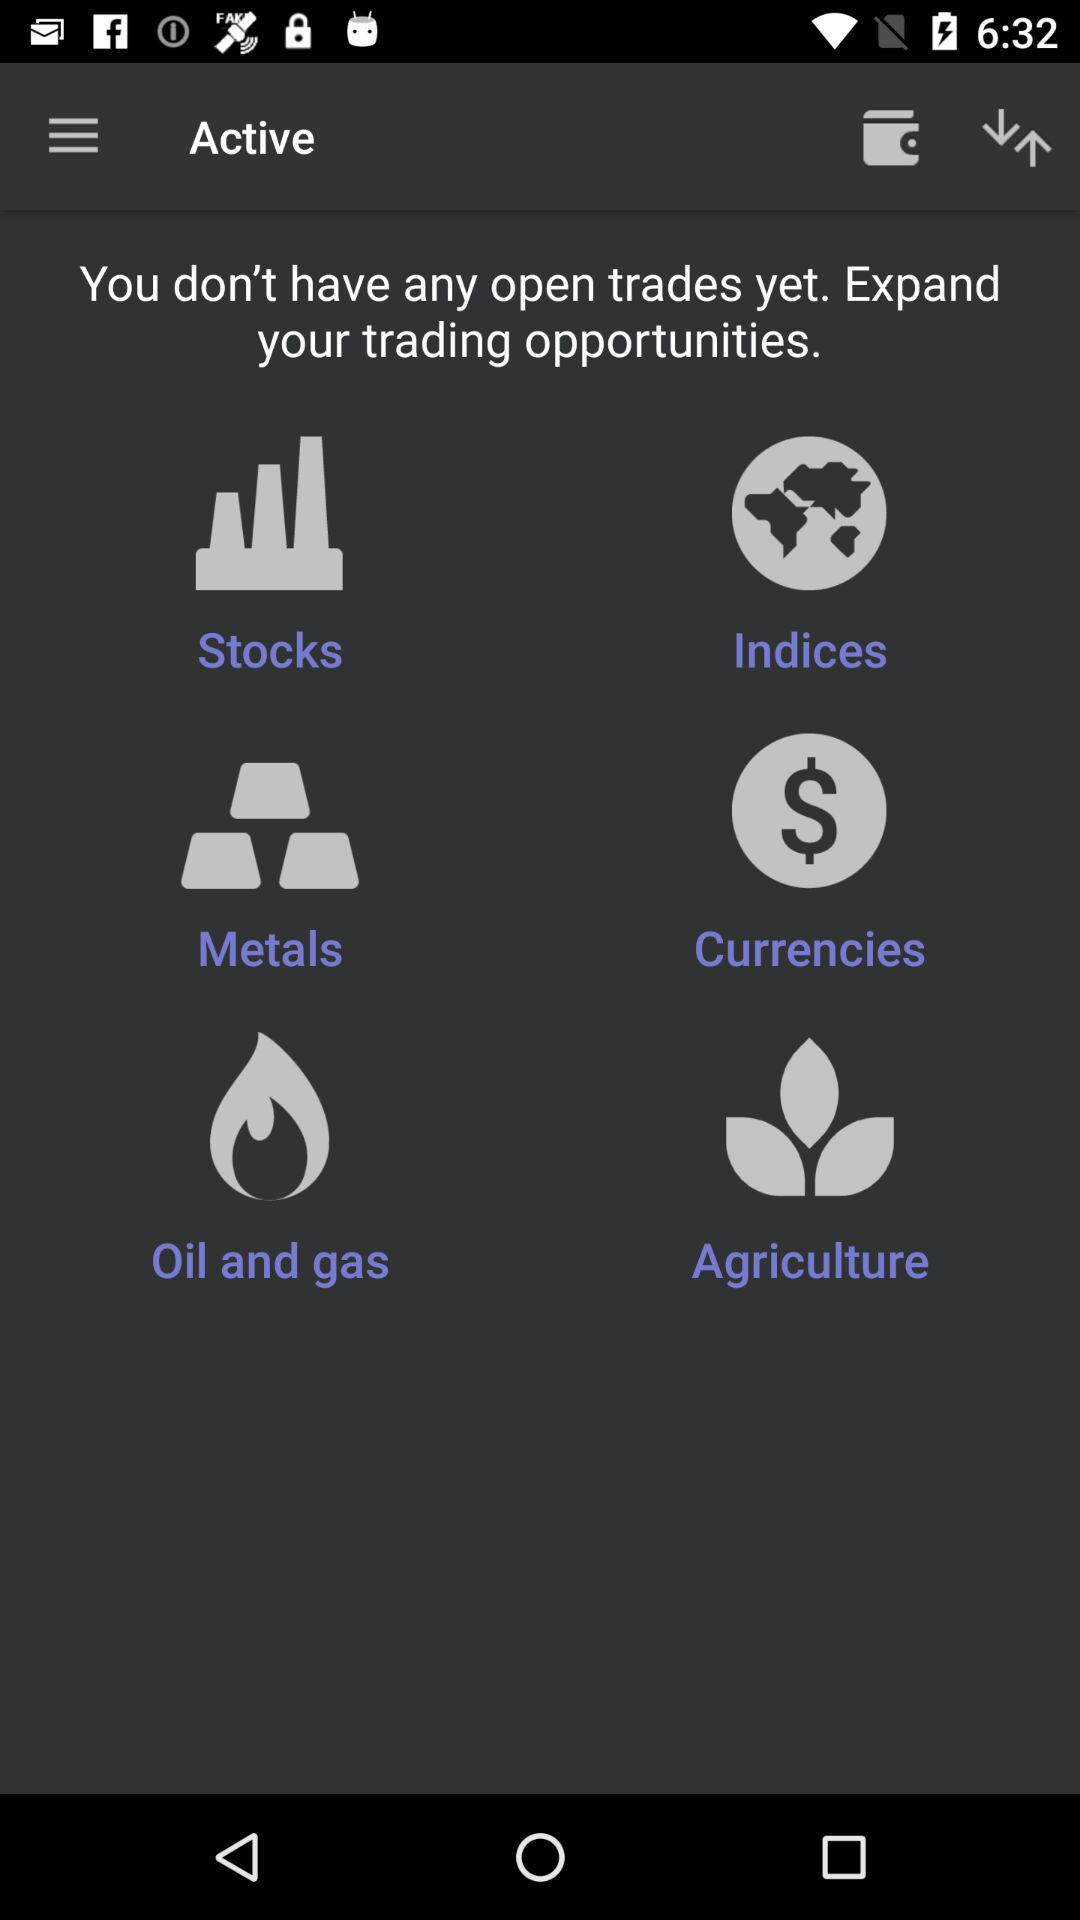What are the trading opportunities in which I can trade? The trading opportunities are "Stocks", "Indices", "Metals", "Currencies", "Oil and gas" and "Agriculture". 